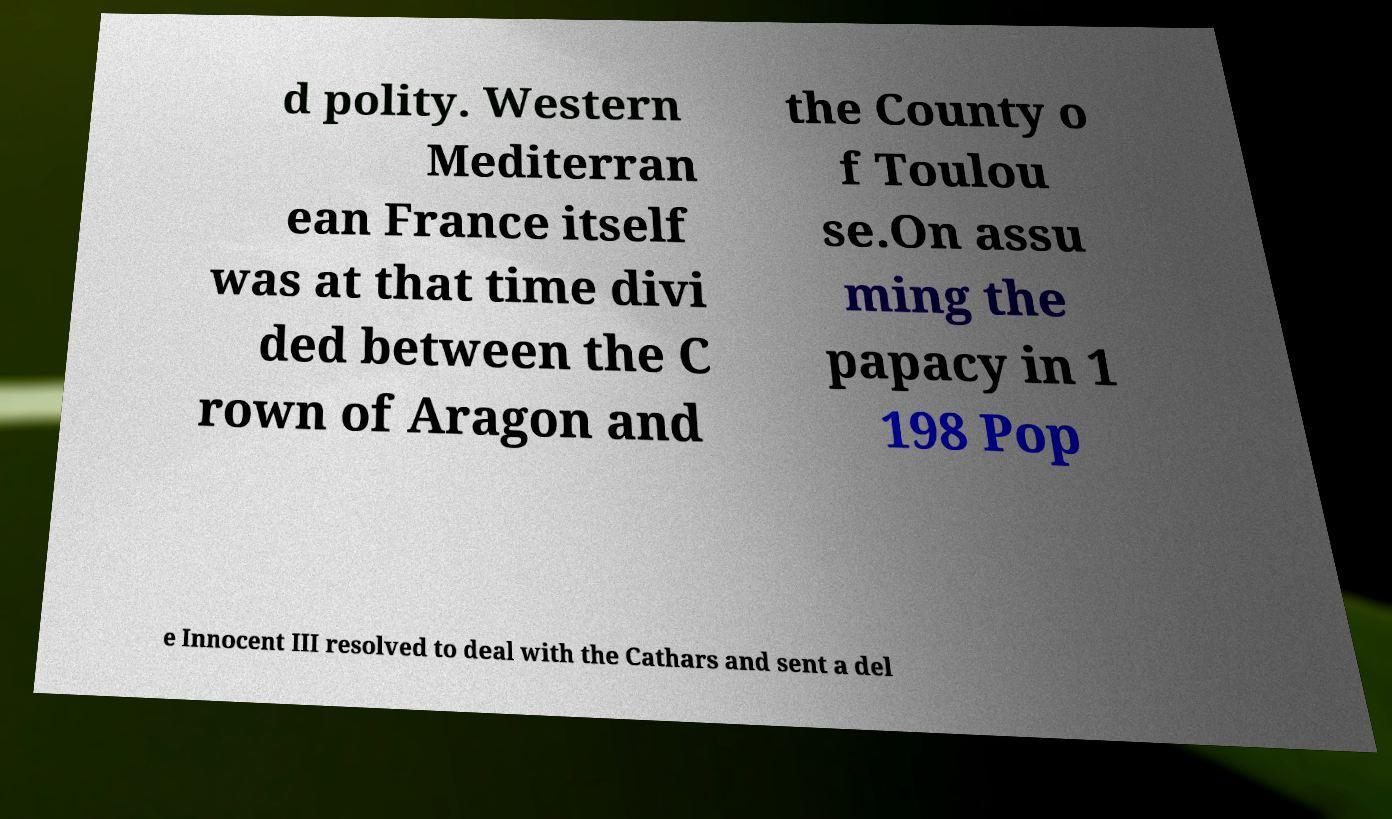Please read and relay the text visible in this image. What does it say? d polity. Western Mediterran ean France itself was at that time divi ded between the C rown of Aragon and the County o f Toulou se.On assu ming the papacy in 1 198 Pop e Innocent III resolved to deal with the Cathars and sent a del 